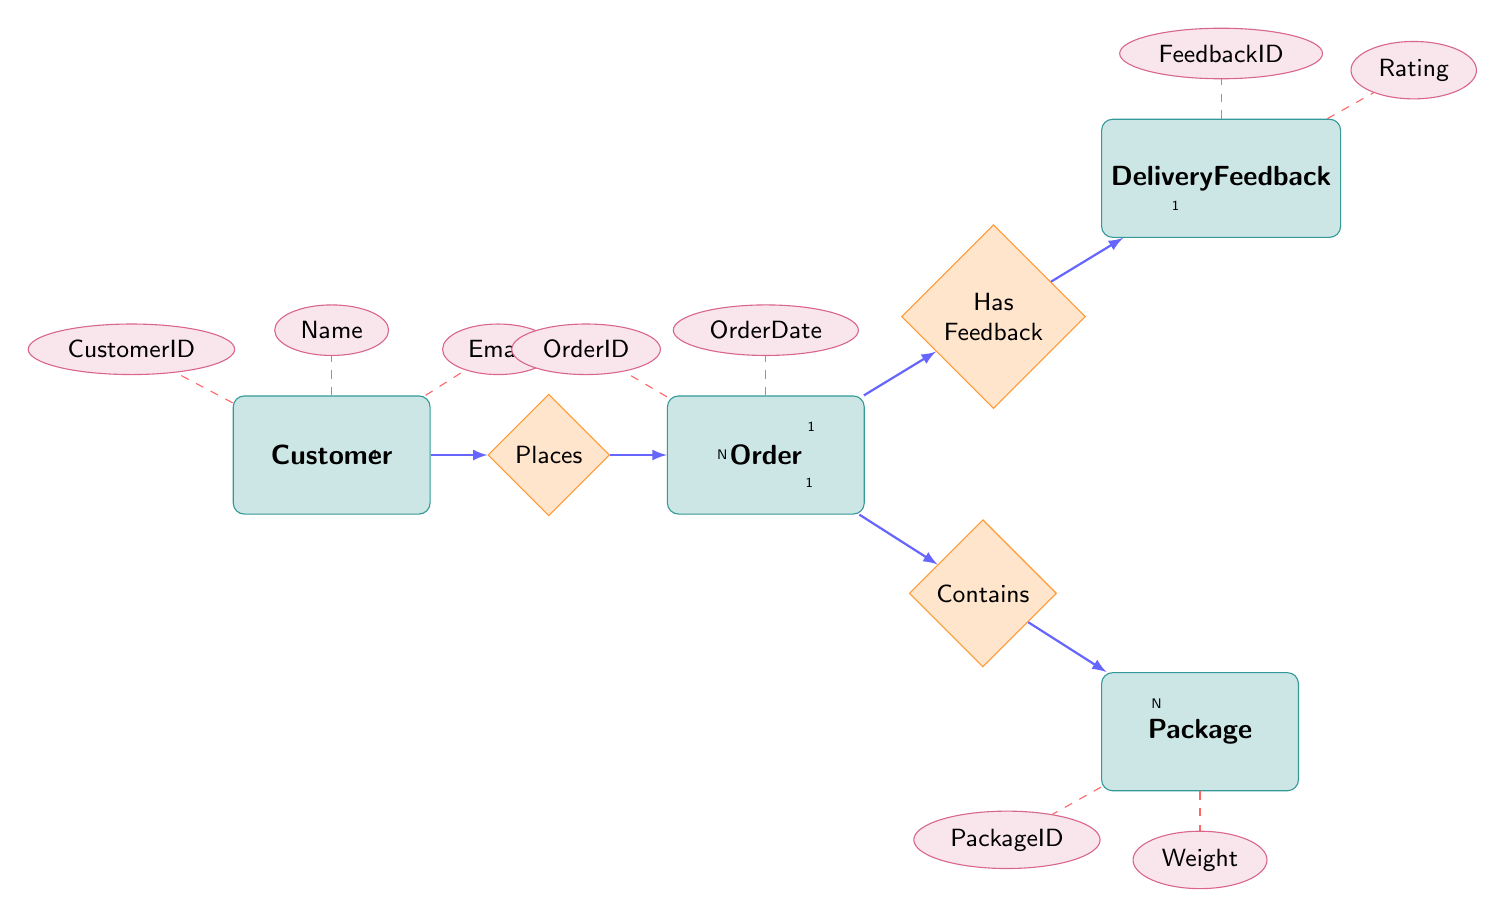What is the relationship type between Customer and Order? The relationship type between Customer and Order is identified as "Places". Since it's a one-to-many relationship, it indicates that one Customer can place multiple Orders.
Answer: One-To-Many How many attributes does the Package entity have? The Package entity has two attributes listed in the diagram: PackageID and Weight. Therefore, counting these gives us a total of two attributes.
Answer: Two What contributes to the Delivery Feedback in this workflow? The Delivery Feedback is directly linked to the Order through the "Has Feedback" relationship. Therefore, the Order is the entity that contributes to the Delivery Feedback.
Answer: Order How many entities are represented in the diagram? The diagram represents four distinct entities: Customer, Order, Package, and Delivery Feedback. By counting these entities, we find there are four in total.
Answer: Four What connects the Package entity to the Order entity? The relationship that connects the Package entity to the Order entity is termed "Part of Order". This shows the direction of how Packages are associated with Orders.
Answer: Part of Order How many Delivery Feedbacks can one Order have? According to the relationship "Has Feedback" in the diagram, each Order can have exactly one Delivery Feedback. This establishes a one-to-one relationship between these two entities.
Answer: One What is the cardinality from Order to Package? The diagram indicates that the cardinality from Order to Package is one-to-many, reflected by the notation. This means one Order can contain multiple Packages.
Answer: One-To-Many What is the attribute name related to Customer's email? The attribute name concerning the Customer's email is "Email", which is designated as one of the attributes for the Customer entity in the diagram.
Answer: Email What is the relationship type between Delivery Feedback and Order? The relationship type between Delivery Feedback and Order is defined as "Related to Order". This indicates a one-to-one relationship, meaning there is one Delivery Feedback for one Order.
Answer: One-To-One 